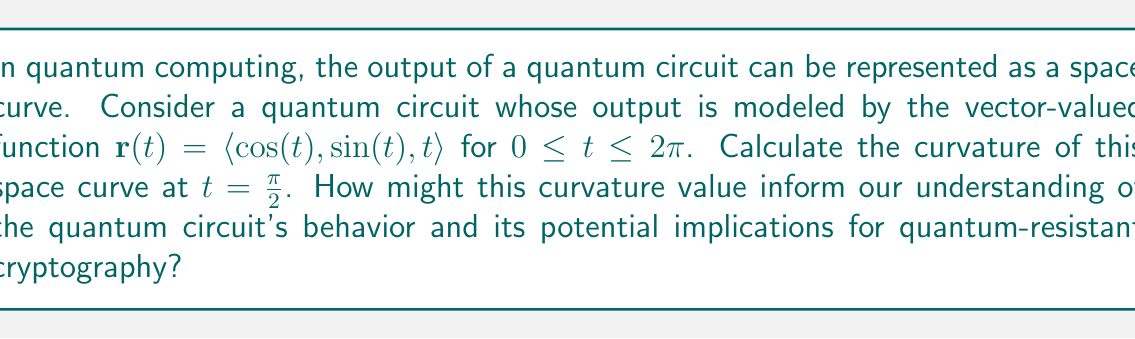Provide a solution to this math problem. To calculate the curvature of the space curve at a specific point, we'll use the formula:

$$\kappa = \frac{|\mathbf{r}'(t) \times \mathbf{r}''(t)|}{|\mathbf{r}'(t)|^3}$$

Where $\mathbf{r}'(t)$ is the first derivative and $\mathbf{r}''(t)$ is the second derivative of the vector-valued function.

Step 1: Calculate $\mathbf{r}'(t)$
$$\mathbf{r}'(t) = \langle -\sin(t), \cos(t), 1 \rangle$$

Step 2: Calculate $\mathbf{r}''(t)$
$$\mathbf{r}''(t) = \langle -\cos(t), -\sin(t), 0 \rangle$$

Step 3: Calculate $\mathbf{r}'(t) \times \mathbf{r}''(t)$
$$\mathbf{r}'(t) \times \mathbf{r}''(t) = \begin{vmatrix} 
\mathbf{i} & \mathbf{j} & \mathbf{k} \\
-\sin(t) & \cos(t) & 1 \\
-\cos(t) & -\sin(t) & 0
\end{vmatrix}$$

$$= \langle -\sin(t), -\cos(t), \sin^2(t) + \cos^2(t) \rangle = \langle -\sin(t), -\cos(t), 1 \rangle$$

Step 4: Calculate $|\mathbf{r}'(t) \times \mathbf{r}''(t)|$
$$|\mathbf{r}'(t) \times \mathbf{r}''(t)| = \sqrt{\sin^2(t) + \cos^2(t) + 1} = \sqrt{2}$$

Step 5: Calculate $|\mathbf{r}'(t)|$
$$|\mathbf{r}'(t)| = \sqrt{\sin^2(t) + \cos^2(t) + 1} = \sqrt{2}$$

Step 6: Apply the curvature formula at $t = \frac{\pi}{2}$
$$\kappa = \frac{|\mathbf{r}'(t) \times \mathbf{r}''(t)|}{|\mathbf{r}'(t)|^3} = \frac{\sqrt{2}}{(\sqrt{2})^3} = \frac{\sqrt{2}}{2\sqrt{2}} = \frac{1}{2}$$

The curvature at $t = \frac{\pi}{2}$ is $\frac{1}{2}$. This constant curvature indicates that the quantum circuit's output follows a uniform circular helix in three-dimensional space. In the context of quantum-resistant cryptography, this regular behavior might suggest that the quantum circuit produces predictable outputs, which could be vulnerable to certain types of attacks. However, a more comprehensive analysis of the entire curve and its properties would be necessary to draw definitive conclusions about the circuit's security implications.
Answer: The curvature of the space curve representing the quantum circuit's output at $t = \frac{\pi}{2}$ is $\frac{1}{2}$. 